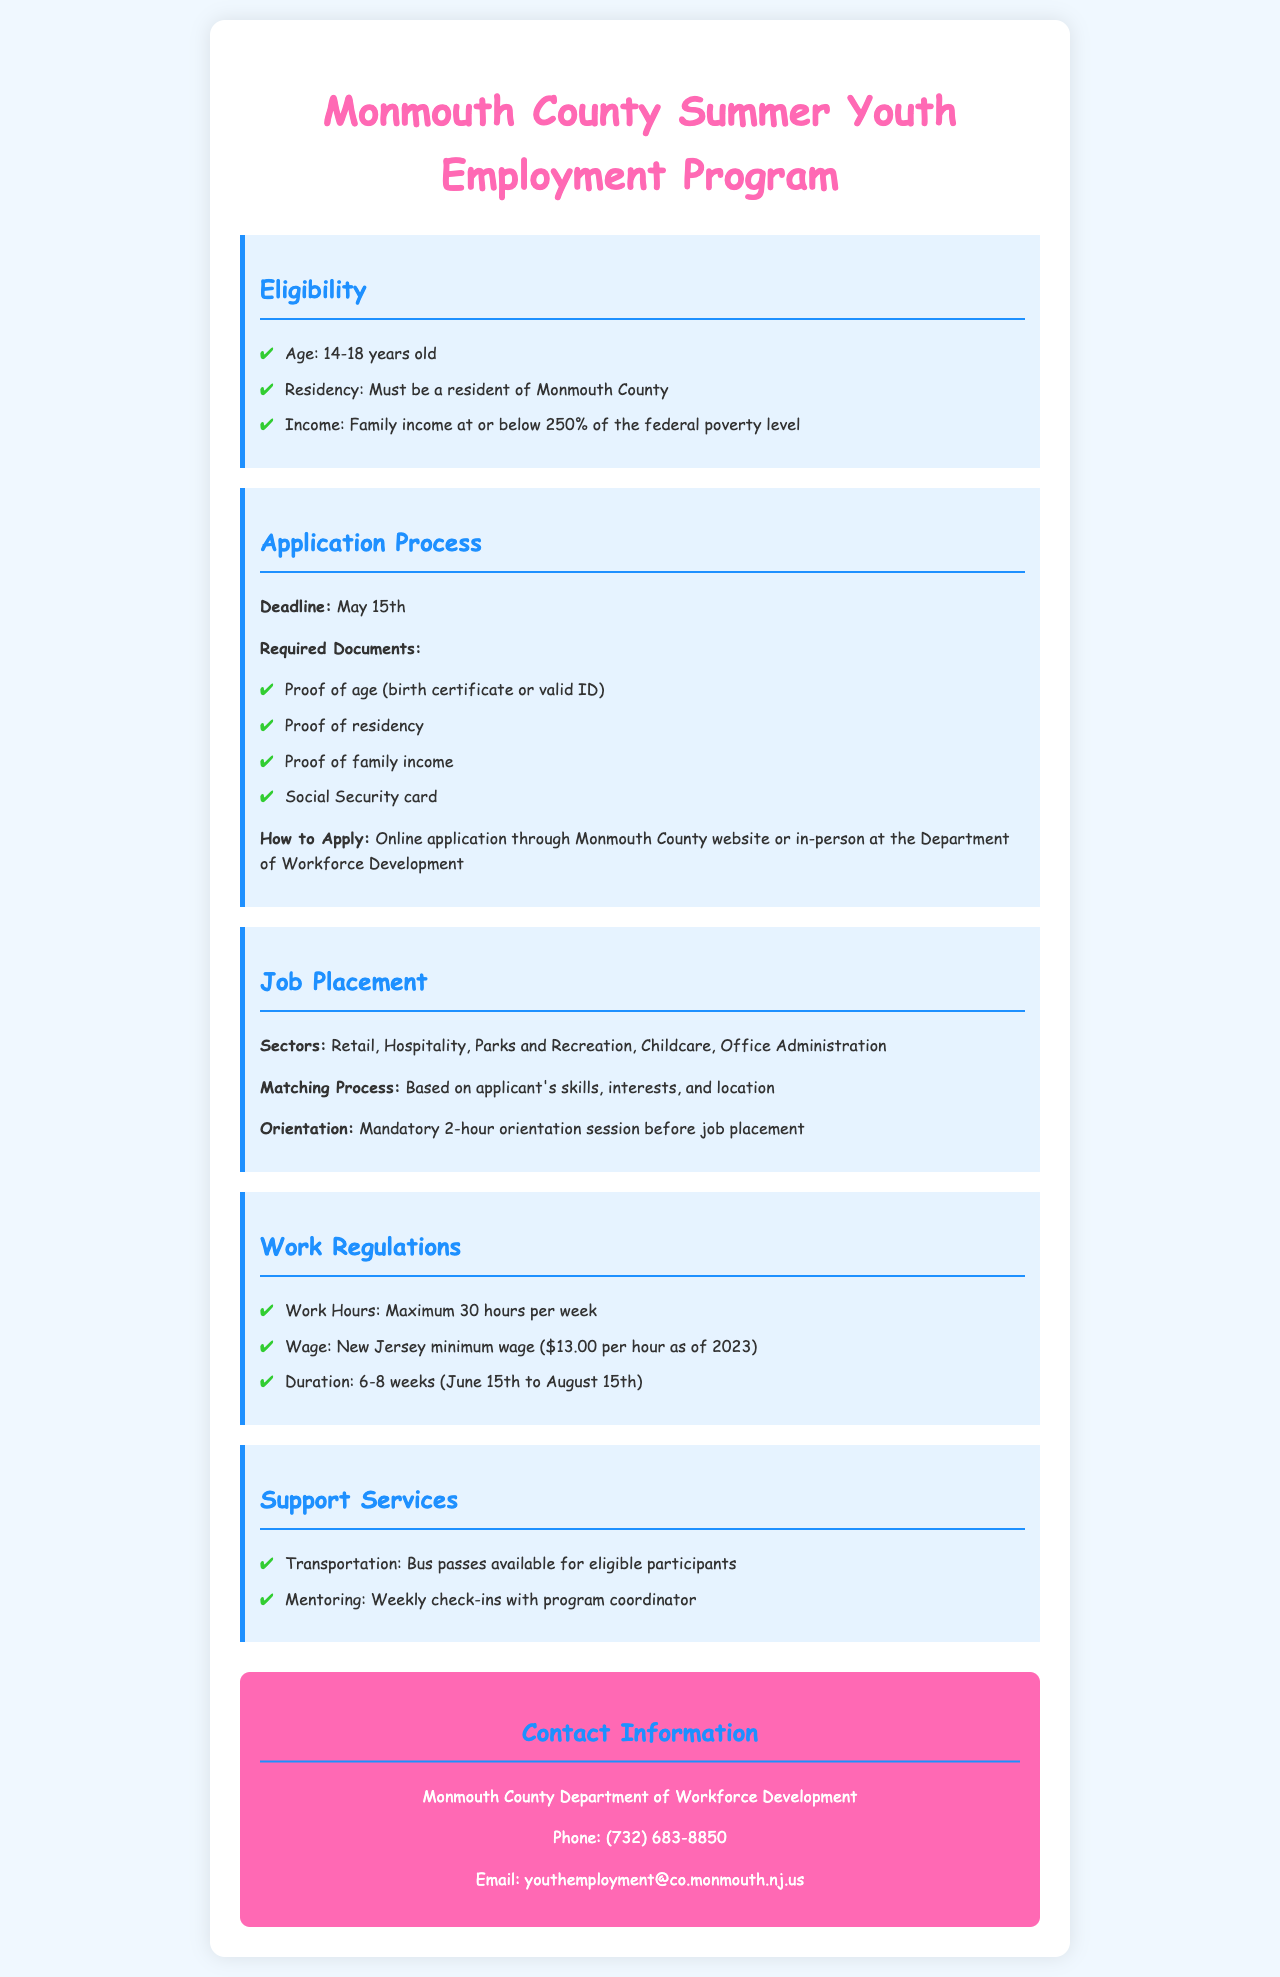What is the age range for eligibility? The document states that the eligibility age range is from 14 to 18 years old.
Answer: 14-18 years old What is the deadline for application? According to the document, the application deadline is specified as May 15th.
Answer: May 15th What is the required wage for participants? The document mentions that the wage is based on the New Jersey minimum wage, which is mentioned as $13.00 per hour as of 2023.
Answer: $13.00 per hour How long is the program duration? The document indicates the program duration lasts from June 15th to August 15th over a span of 6-8 weeks.
Answer: 6-8 weeks What is required proof of residency? The document requires proof of residency to be submitted as part of the application process.
Answer: Proof of residency What sectors are included for job placement? The document lists various sectors available for job placement, including Retail, Hospitality, Parks and Recreation, Childcare, and Office Administration.
Answer: Retail, Hospitality, Parks and Recreation, Childcare, Office Administration What is the maximum number of work hours per week? The document specifies that the maximum work hours allowed per week is 30.
Answer: 30 hours What support services are provided? The document mentions support services such as transportation with available bus passes and weekly mentoring check-ins with the program coordinator.
Answer: Transportation, Mentoring What document is required as proof of age? The document states that proof of age can be a birth certificate or valid ID.
Answer: Birth certificate or valid ID 